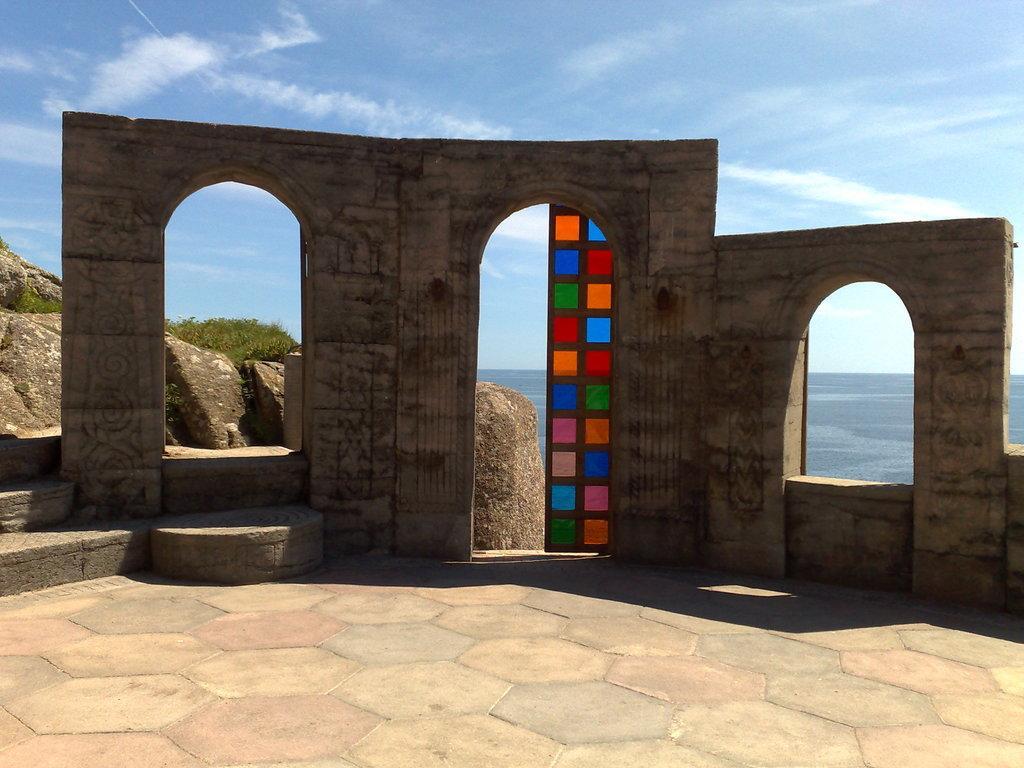Could you give a brief overview of what you see in this image? In the foreground of the picture it is floor. In the middle we can see walls and a door. On the left we can see rocks and grass. In the background towards right there is a water body. At the top it is sky. 